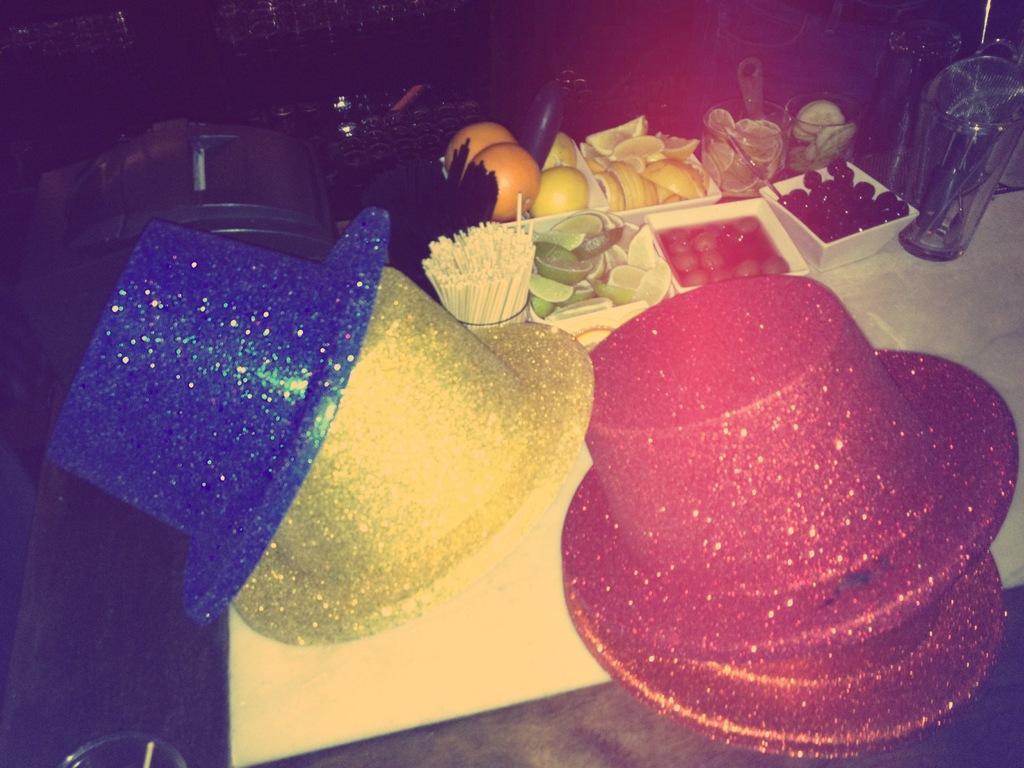Please provide a concise description of this image. In this picture there are few hats which are in different colors and there are few eatables and some other objects beside it. 